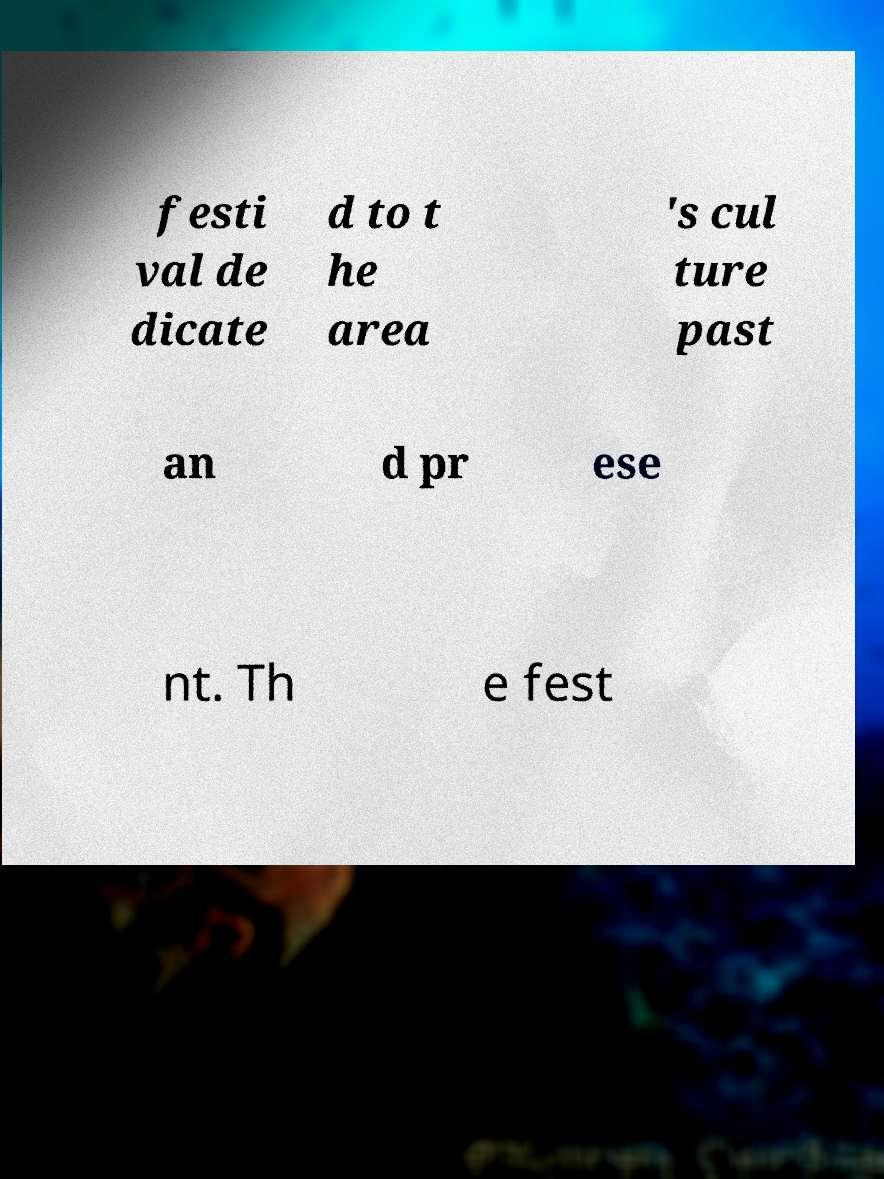Please read and relay the text visible in this image. What does it say? festi val de dicate d to t he area 's cul ture past an d pr ese nt. Th e fest 